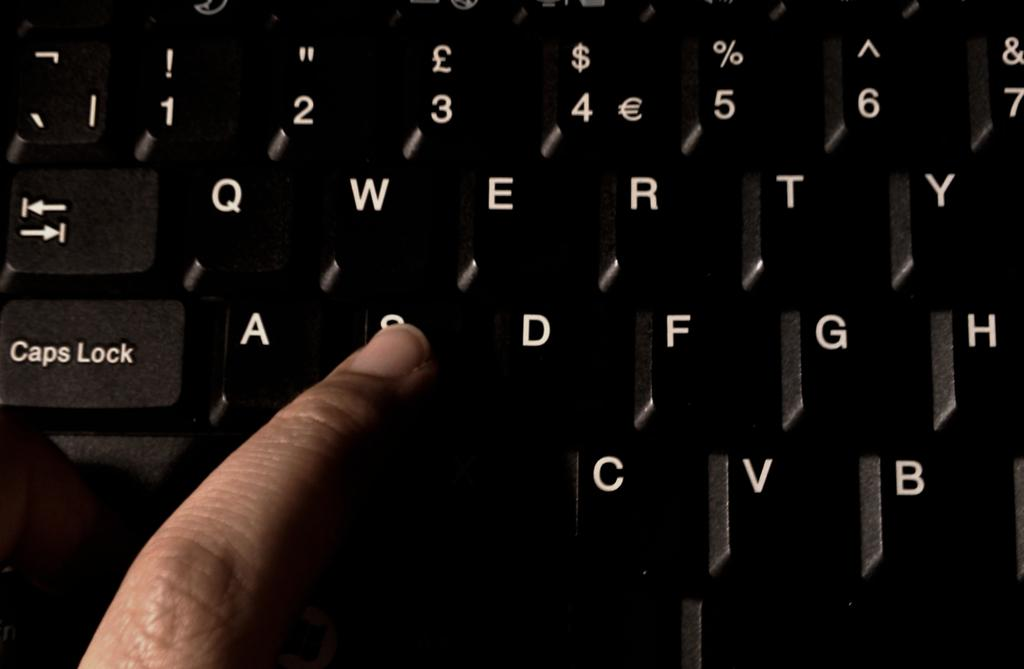<image>
Present a compact description of the photo's key features. a person's finger pressing down on keyboard key 's' 